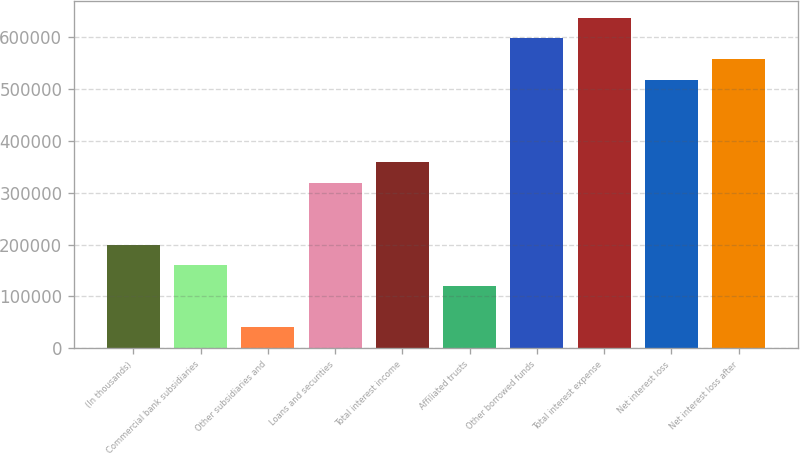Convert chart. <chart><loc_0><loc_0><loc_500><loc_500><bar_chart><fcel>(In thousands)<fcel>Commercial bank subsidiaries<fcel>Other subsidiaries and<fcel>Loans and securities<fcel>Total interest income<fcel>Affiliated trusts<fcel>Other borrowed funds<fcel>Total interest expense<fcel>Net interest loss<fcel>Net interest loss after<nl><fcel>199431<fcel>159625<fcel>40206.2<fcel>318850<fcel>358656<fcel>119819<fcel>597493<fcel>637299<fcel>517881<fcel>557687<nl></chart> 